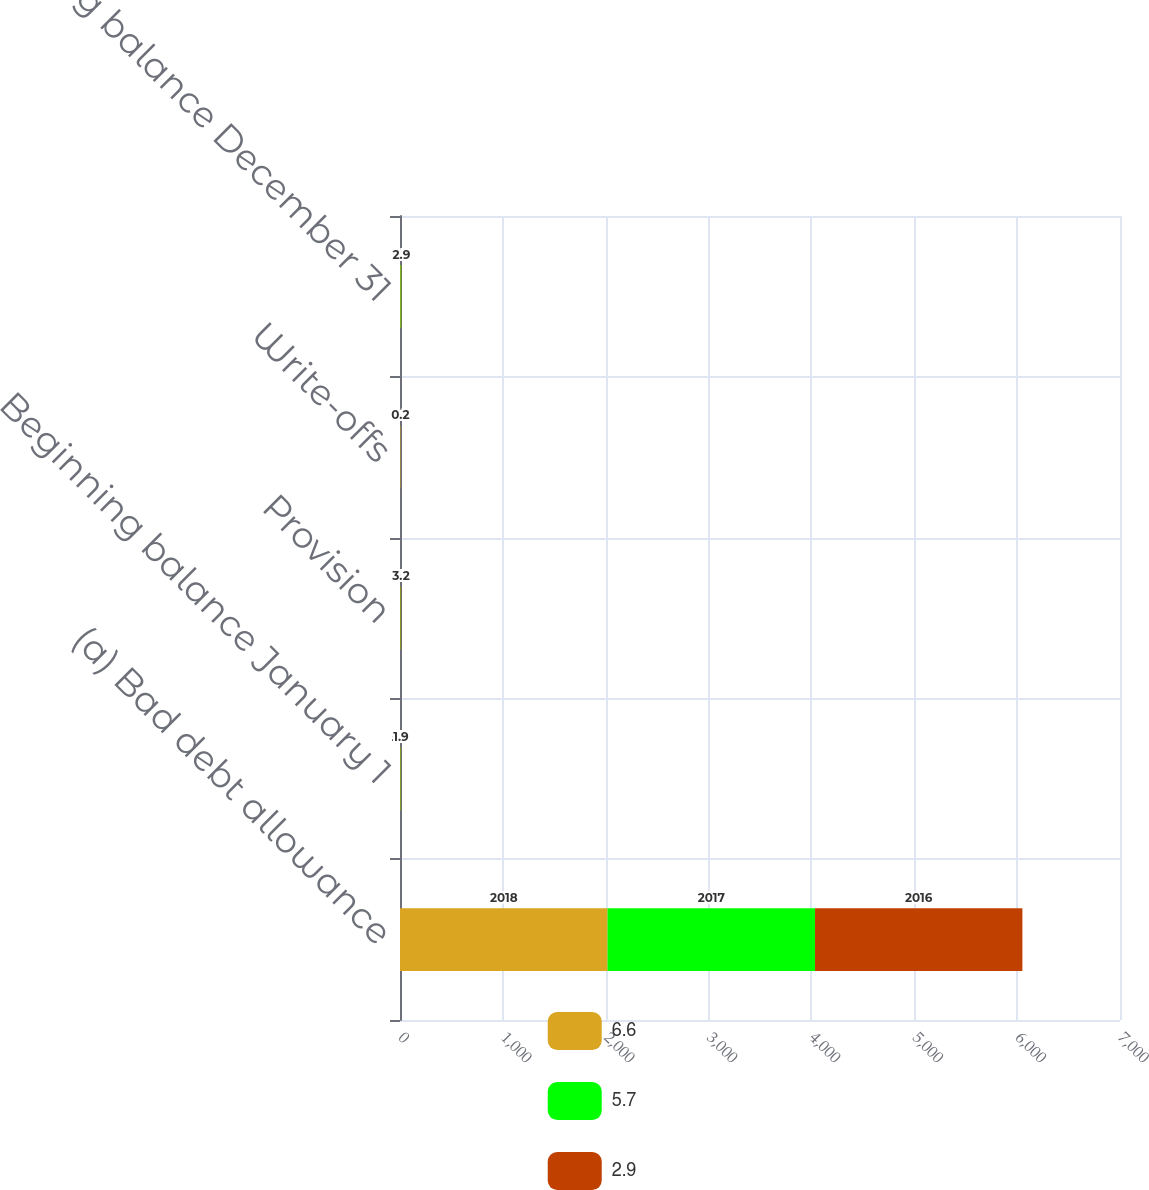<chart> <loc_0><loc_0><loc_500><loc_500><stacked_bar_chart><ecel><fcel>(a) Bad debt allowance<fcel>Beginning balance January 1<fcel>Provision<fcel>Write-offs<fcel>Ending balance December 31<nl><fcel>6.6<fcel>2018<fcel>5.7<fcel>5.3<fcel>4.2<fcel>6.6<nl><fcel>5.7<fcel>2017<fcel>2.9<fcel>2.7<fcel>0.1<fcel>5.7<nl><fcel>2.9<fcel>2016<fcel>1.9<fcel>3.2<fcel>0.2<fcel>2.9<nl></chart> 